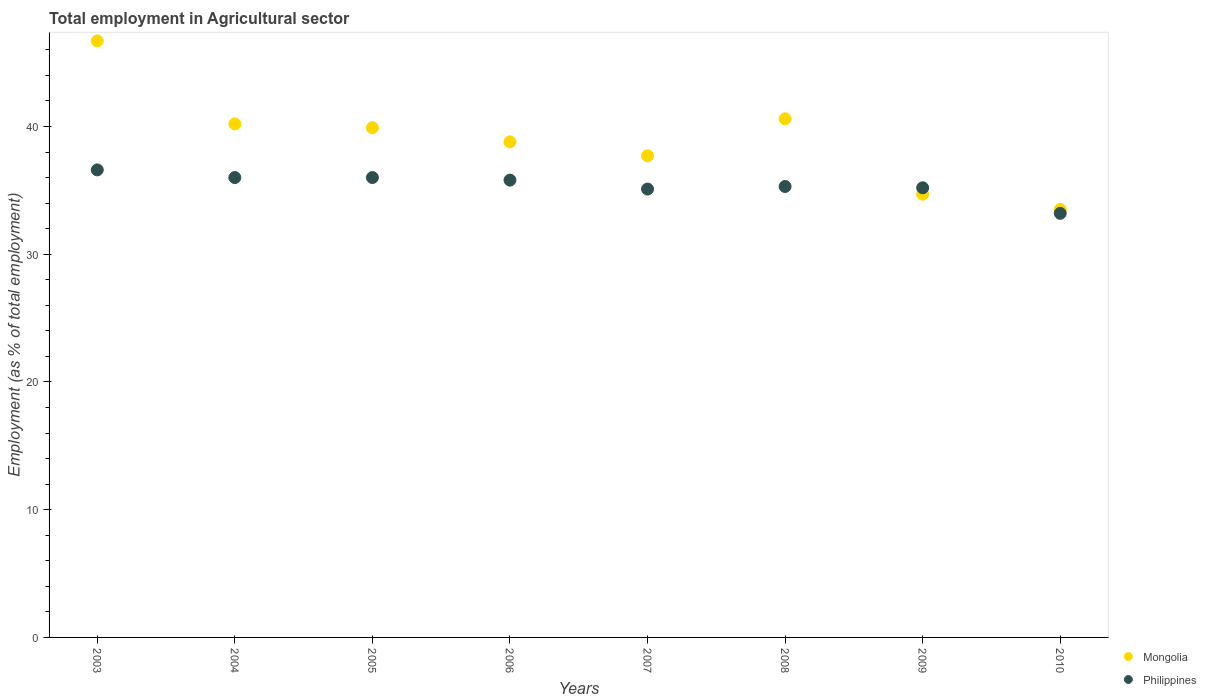How many different coloured dotlines are there?
Ensure brevity in your answer.  2. What is the employment in agricultural sector in Philippines in 2007?
Make the answer very short. 35.1. Across all years, what is the maximum employment in agricultural sector in Mongolia?
Keep it short and to the point. 46.7. Across all years, what is the minimum employment in agricultural sector in Philippines?
Ensure brevity in your answer.  33.2. What is the total employment in agricultural sector in Philippines in the graph?
Your answer should be very brief. 283.2. What is the difference between the employment in agricultural sector in Mongolia in 2008 and that in 2009?
Make the answer very short. 5.9. What is the difference between the employment in agricultural sector in Philippines in 2007 and the employment in agricultural sector in Mongolia in 2010?
Your answer should be very brief. 1.6. What is the average employment in agricultural sector in Philippines per year?
Give a very brief answer. 35.4. In the year 2004, what is the difference between the employment in agricultural sector in Mongolia and employment in agricultural sector in Philippines?
Give a very brief answer. 4.2. What is the ratio of the employment in agricultural sector in Mongolia in 2005 to that in 2009?
Give a very brief answer. 1.15. What is the difference between the highest and the second highest employment in agricultural sector in Mongolia?
Ensure brevity in your answer.  6.1. What is the difference between the highest and the lowest employment in agricultural sector in Philippines?
Give a very brief answer. 3.4. In how many years, is the employment in agricultural sector in Mongolia greater than the average employment in agricultural sector in Mongolia taken over all years?
Give a very brief answer. 4. Is the sum of the employment in agricultural sector in Philippines in 2007 and 2010 greater than the maximum employment in agricultural sector in Mongolia across all years?
Provide a succinct answer. Yes. Is the employment in agricultural sector in Philippines strictly less than the employment in agricultural sector in Mongolia over the years?
Offer a terse response. No. How many dotlines are there?
Give a very brief answer. 2. How many years are there in the graph?
Give a very brief answer. 8. How many legend labels are there?
Offer a very short reply. 2. What is the title of the graph?
Ensure brevity in your answer.  Total employment in Agricultural sector. Does "Timor-Leste" appear as one of the legend labels in the graph?
Your answer should be compact. No. What is the label or title of the Y-axis?
Make the answer very short. Employment (as % of total employment). What is the Employment (as % of total employment) of Mongolia in 2003?
Provide a short and direct response. 46.7. What is the Employment (as % of total employment) in Philippines in 2003?
Offer a terse response. 36.6. What is the Employment (as % of total employment) in Mongolia in 2004?
Your answer should be compact. 40.2. What is the Employment (as % of total employment) in Philippines in 2004?
Your answer should be compact. 36. What is the Employment (as % of total employment) in Mongolia in 2005?
Offer a very short reply. 39.9. What is the Employment (as % of total employment) in Mongolia in 2006?
Provide a succinct answer. 38.8. What is the Employment (as % of total employment) of Philippines in 2006?
Keep it short and to the point. 35.8. What is the Employment (as % of total employment) of Mongolia in 2007?
Your answer should be compact. 37.7. What is the Employment (as % of total employment) of Philippines in 2007?
Your response must be concise. 35.1. What is the Employment (as % of total employment) in Mongolia in 2008?
Provide a succinct answer. 40.6. What is the Employment (as % of total employment) of Philippines in 2008?
Your response must be concise. 35.3. What is the Employment (as % of total employment) in Mongolia in 2009?
Offer a terse response. 34.7. What is the Employment (as % of total employment) in Philippines in 2009?
Offer a very short reply. 35.2. What is the Employment (as % of total employment) in Mongolia in 2010?
Give a very brief answer. 33.5. What is the Employment (as % of total employment) of Philippines in 2010?
Make the answer very short. 33.2. Across all years, what is the maximum Employment (as % of total employment) in Mongolia?
Keep it short and to the point. 46.7. Across all years, what is the maximum Employment (as % of total employment) of Philippines?
Offer a terse response. 36.6. Across all years, what is the minimum Employment (as % of total employment) of Mongolia?
Keep it short and to the point. 33.5. Across all years, what is the minimum Employment (as % of total employment) of Philippines?
Your answer should be compact. 33.2. What is the total Employment (as % of total employment) of Mongolia in the graph?
Provide a short and direct response. 312.1. What is the total Employment (as % of total employment) in Philippines in the graph?
Your answer should be very brief. 283.2. What is the difference between the Employment (as % of total employment) in Mongolia in 2003 and that in 2004?
Your response must be concise. 6.5. What is the difference between the Employment (as % of total employment) of Philippines in 2003 and that in 2004?
Your answer should be very brief. 0.6. What is the difference between the Employment (as % of total employment) of Mongolia in 2003 and that in 2005?
Your answer should be compact. 6.8. What is the difference between the Employment (as % of total employment) in Mongolia in 2003 and that in 2006?
Keep it short and to the point. 7.9. What is the difference between the Employment (as % of total employment) in Philippines in 2003 and that in 2006?
Your answer should be very brief. 0.8. What is the difference between the Employment (as % of total employment) in Philippines in 2003 and that in 2007?
Offer a very short reply. 1.5. What is the difference between the Employment (as % of total employment) of Philippines in 2003 and that in 2008?
Provide a short and direct response. 1.3. What is the difference between the Employment (as % of total employment) in Mongolia in 2003 and that in 2010?
Offer a terse response. 13.2. What is the difference between the Employment (as % of total employment) of Mongolia in 2004 and that in 2005?
Your answer should be compact. 0.3. What is the difference between the Employment (as % of total employment) of Philippines in 2004 and that in 2006?
Your answer should be very brief. 0.2. What is the difference between the Employment (as % of total employment) in Mongolia in 2004 and that in 2007?
Ensure brevity in your answer.  2.5. What is the difference between the Employment (as % of total employment) of Mongolia in 2004 and that in 2008?
Your response must be concise. -0.4. What is the difference between the Employment (as % of total employment) in Philippines in 2004 and that in 2008?
Your response must be concise. 0.7. What is the difference between the Employment (as % of total employment) in Mongolia in 2004 and that in 2009?
Keep it short and to the point. 5.5. What is the difference between the Employment (as % of total employment) in Mongolia in 2004 and that in 2010?
Your answer should be very brief. 6.7. What is the difference between the Employment (as % of total employment) of Philippines in 2004 and that in 2010?
Your answer should be compact. 2.8. What is the difference between the Employment (as % of total employment) in Mongolia in 2005 and that in 2006?
Your answer should be compact. 1.1. What is the difference between the Employment (as % of total employment) of Mongolia in 2005 and that in 2007?
Your answer should be compact. 2.2. What is the difference between the Employment (as % of total employment) of Philippines in 2005 and that in 2007?
Ensure brevity in your answer.  0.9. What is the difference between the Employment (as % of total employment) of Mongolia in 2005 and that in 2008?
Provide a succinct answer. -0.7. What is the difference between the Employment (as % of total employment) in Philippines in 2005 and that in 2008?
Your response must be concise. 0.7. What is the difference between the Employment (as % of total employment) in Philippines in 2005 and that in 2010?
Your response must be concise. 2.8. What is the difference between the Employment (as % of total employment) in Mongolia in 2006 and that in 2007?
Your response must be concise. 1.1. What is the difference between the Employment (as % of total employment) of Mongolia in 2006 and that in 2008?
Provide a short and direct response. -1.8. What is the difference between the Employment (as % of total employment) in Philippines in 2006 and that in 2008?
Ensure brevity in your answer.  0.5. What is the difference between the Employment (as % of total employment) of Mongolia in 2006 and that in 2009?
Provide a short and direct response. 4.1. What is the difference between the Employment (as % of total employment) of Mongolia in 2008 and that in 2009?
Your answer should be very brief. 5.9. What is the difference between the Employment (as % of total employment) of Mongolia in 2009 and that in 2010?
Make the answer very short. 1.2. What is the difference between the Employment (as % of total employment) in Philippines in 2009 and that in 2010?
Provide a succinct answer. 2. What is the difference between the Employment (as % of total employment) of Mongolia in 2003 and the Employment (as % of total employment) of Philippines in 2004?
Give a very brief answer. 10.7. What is the difference between the Employment (as % of total employment) in Mongolia in 2003 and the Employment (as % of total employment) in Philippines in 2007?
Offer a terse response. 11.6. What is the difference between the Employment (as % of total employment) in Mongolia in 2003 and the Employment (as % of total employment) in Philippines in 2008?
Make the answer very short. 11.4. What is the difference between the Employment (as % of total employment) in Mongolia in 2003 and the Employment (as % of total employment) in Philippines in 2009?
Your answer should be compact. 11.5. What is the difference between the Employment (as % of total employment) of Mongolia in 2004 and the Employment (as % of total employment) of Philippines in 2006?
Make the answer very short. 4.4. What is the difference between the Employment (as % of total employment) of Mongolia in 2004 and the Employment (as % of total employment) of Philippines in 2007?
Give a very brief answer. 5.1. What is the difference between the Employment (as % of total employment) in Mongolia in 2004 and the Employment (as % of total employment) in Philippines in 2010?
Keep it short and to the point. 7. What is the difference between the Employment (as % of total employment) in Mongolia in 2005 and the Employment (as % of total employment) in Philippines in 2009?
Ensure brevity in your answer.  4.7. What is the difference between the Employment (as % of total employment) of Mongolia in 2007 and the Employment (as % of total employment) of Philippines in 2009?
Provide a succinct answer. 2.5. What is the difference between the Employment (as % of total employment) of Mongolia in 2007 and the Employment (as % of total employment) of Philippines in 2010?
Your response must be concise. 4.5. What is the difference between the Employment (as % of total employment) in Mongolia in 2008 and the Employment (as % of total employment) in Philippines in 2009?
Provide a short and direct response. 5.4. What is the average Employment (as % of total employment) of Mongolia per year?
Your response must be concise. 39.01. What is the average Employment (as % of total employment) of Philippines per year?
Your response must be concise. 35.4. In the year 2004, what is the difference between the Employment (as % of total employment) in Mongolia and Employment (as % of total employment) in Philippines?
Offer a very short reply. 4.2. In the year 2006, what is the difference between the Employment (as % of total employment) of Mongolia and Employment (as % of total employment) of Philippines?
Provide a short and direct response. 3. In the year 2008, what is the difference between the Employment (as % of total employment) of Mongolia and Employment (as % of total employment) of Philippines?
Give a very brief answer. 5.3. In the year 2009, what is the difference between the Employment (as % of total employment) in Mongolia and Employment (as % of total employment) in Philippines?
Your answer should be compact. -0.5. In the year 2010, what is the difference between the Employment (as % of total employment) of Mongolia and Employment (as % of total employment) of Philippines?
Offer a terse response. 0.3. What is the ratio of the Employment (as % of total employment) of Mongolia in 2003 to that in 2004?
Give a very brief answer. 1.16. What is the ratio of the Employment (as % of total employment) of Philippines in 2003 to that in 2004?
Offer a terse response. 1.02. What is the ratio of the Employment (as % of total employment) of Mongolia in 2003 to that in 2005?
Provide a succinct answer. 1.17. What is the ratio of the Employment (as % of total employment) in Philippines in 2003 to that in 2005?
Your answer should be compact. 1.02. What is the ratio of the Employment (as % of total employment) of Mongolia in 2003 to that in 2006?
Provide a short and direct response. 1.2. What is the ratio of the Employment (as % of total employment) of Philippines in 2003 to that in 2006?
Your answer should be compact. 1.02. What is the ratio of the Employment (as % of total employment) of Mongolia in 2003 to that in 2007?
Your answer should be very brief. 1.24. What is the ratio of the Employment (as % of total employment) of Philippines in 2003 to that in 2007?
Offer a terse response. 1.04. What is the ratio of the Employment (as % of total employment) of Mongolia in 2003 to that in 2008?
Ensure brevity in your answer.  1.15. What is the ratio of the Employment (as % of total employment) of Philippines in 2003 to that in 2008?
Offer a very short reply. 1.04. What is the ratio of the Employment (as % of total employment) of Mongolia in 2003 to that in 2009?
Make the answer very short. 1.35. What is the ratio of the Employment (as % of total employment) of Philippines in 2003 to that in 2009?
Make the answer very short. 1.04. What is the ratio of the Employment (as % of total employment) in Mongolia in 2003 to that in 2010?
Keep it short and to the point. 1.39. What is the ratio of the Employment (as % of total employment) of Philippines in 2003 to that in 2010?
Make the answer very short. 1.1. What is the ratio of the Employment (as % of total employment) in Mongolia in 2004 to that in 2005?
Provide a succinct answer. 1.01. What is the ratio of the Employment (as % of total employment) of Mongolia in 2004 to that in 2006?
Offer a very short reply. 1.04. What is the ratio of the Employment (as % of total employment) of Philippines in 2004 to that in 2006?
Keep it short and to the point. 1.01. What is the ratio of the Employment (as % of total employment) of Mongolia in 2004 to that in 2007?
Keep it short and to the point. 1.07. What is the ratio of the Employment (as % of total employment) of Philippines in 2004 to that in 2007?
Your response must be concise. 1.03. What is the ratio of the Employment (as % of total employment) in Philippines in 2004 to that in 2008?
Your answer should be very brief. 1.02. What is the ratio of the Employment (as % of total employment) in Mongolia in 2004 to that in 2009?
Your answer should be very brief. 1.16. What is the ratio of the Employment (as % of total employment) of Philippines in 2004 to that in 2009?
Make the answer very short. 1.02. What is the ratio of the Employment (as % of total employment) in Mongolia in 2004 to that in 2010?
Your response must be concise. 1.2. What is the ratio of the Employment (as % of total employment) in Philippines in 2004 to that in 2010?
Offer a very short reply. 1.08. What is the ratio of the Employment (as % of total employment) in Mongolia in 2005 to that in 2006?
Provide a succinct answer. 1.03. What is the ratio of the Employment (as % of total employment) of Philippines in 2005 to that in 2006?
Make the answer very short. 1.01. What is the ratio of the Employment (as % of total employment) in Mongolia in 2005 to that in 2007?
Your answer should be compact. 1.06. What is the ratio of the Employment (as % of total employment) of Philippines in 2005 to that in 2007?
Offer a very short reply. 1.03. What is the ratio of the Employment (as % of total employment) in Mongolia in 2005 to that in 2008?
Provide a succinct answer. 0.98. What is the ratio of the Employment (as % of total employment) in Philippines in 2005 to that in 2008?
Provide a succinct answer. 1.02. What is the ratio of the Employment (as % of total employment) in Mongolia in 2005 to that in 2009?
Keep it short and to the point. 1.15. What is the ratio of the Employment (as % of total employment) of Philippines in 2005 to that in 2009?
Offer a very short reply. 1.02. What is the ratio of the Employment (as % of total employment) in Mongolia in 2005 to that in 2010?
Ensure brevity in your answer.  1.19. What is the ratio of the Employment (as % of total employment) of Philippines in 2005 to that in 2010?
Your answer should be very brief. 1.08. What is the ratio of the Employment (as % of total employment) of Mongolia in 2006 to that in 2007?
Your answer should be very brief. 1.03. What is the ratio of the Employment (as % of total employment) of Philippines in 2006 to that in 2007?
Your answer should be compact. 1.02. What is the ratio of the Employment (as % of total employment) in Mongolia in 2006 to that in 2008?
Ensure brevity in your answer.  0.96. What is the ratio of the Employment (as % of total employment) of Philippines in 2006 to that in 2008?
Your answer should be very brief. 1.01. What is the ratio of the Employment (as % of total employment) of Mongolia in 2006 to that in 2009?
Your answer should be compact. 1.12. What is the ratio of the Employment (as % of total employment) in Mongolia in 2006 to that in 2010?
Give a very brief answer. 1.16. What is the ratio of the Employment (as % of total employment) in Philippines in 2006 to that in 2010?
Give a very brief answer. 1.08. What is the ratio of the Employment (as % of total employment) in Mongolia in 2007 to that in 2008?
Offer a terse response. 0.93. What is the ratio of the Employment (as % of total employment) of Philippines in 2007 to that in 2008?
Ensure brevity in your answer.  0.99. What is the ratio of the Employment (as % of total employment) of Mongolia in 2007 to that in 2009?
Offer a terse response. 1.09. What is the ratio of the Employment (as % of total employment) of Philippines in 2007 to that in 2009?
Your response must be concise. 1. What is the ratio of the Employment (as % of total employment) of Mongolia in 2007 to that in 2010?
Your response must be concise. 1.13. What is the ratio of the Employment (as % of total employment) of Philippines in 2007 to that in 2010?
Offer a terse response. 1.06. What is the ratio of the Employment (as % of total employment) in Mongolia in 2008 to that in 2009?
Keep it short and to the point. 1.17. What is the ratio of the Employment (as % of total employment) in Philippines in 2008 to that in 2009?
Keep it short and to the point. 1. What is the ratio of the Employment (as % of total employment) in Mongolia in 2008 to that in 2010?
Provide a short and direct response. 1.21. What is the ratio of the Employment (as % of total employment) in Philippines in 2008 to that in 2010?
Your answer should be compact. 1.06. What is the ratio of the Employment (as % of total employment) in Mongolia in 2009 to that in 2010?
Your response must be concise. 1.04. What is the ratio of the Employment (as % of total employment) in Philippines in 2009 to that in 2010?
Offer a terse response. 1.06. What is the difference between the highest and the lowest Employment (as % of total employment) of Mongolia?
Your answer should be very brief. 13.2. 